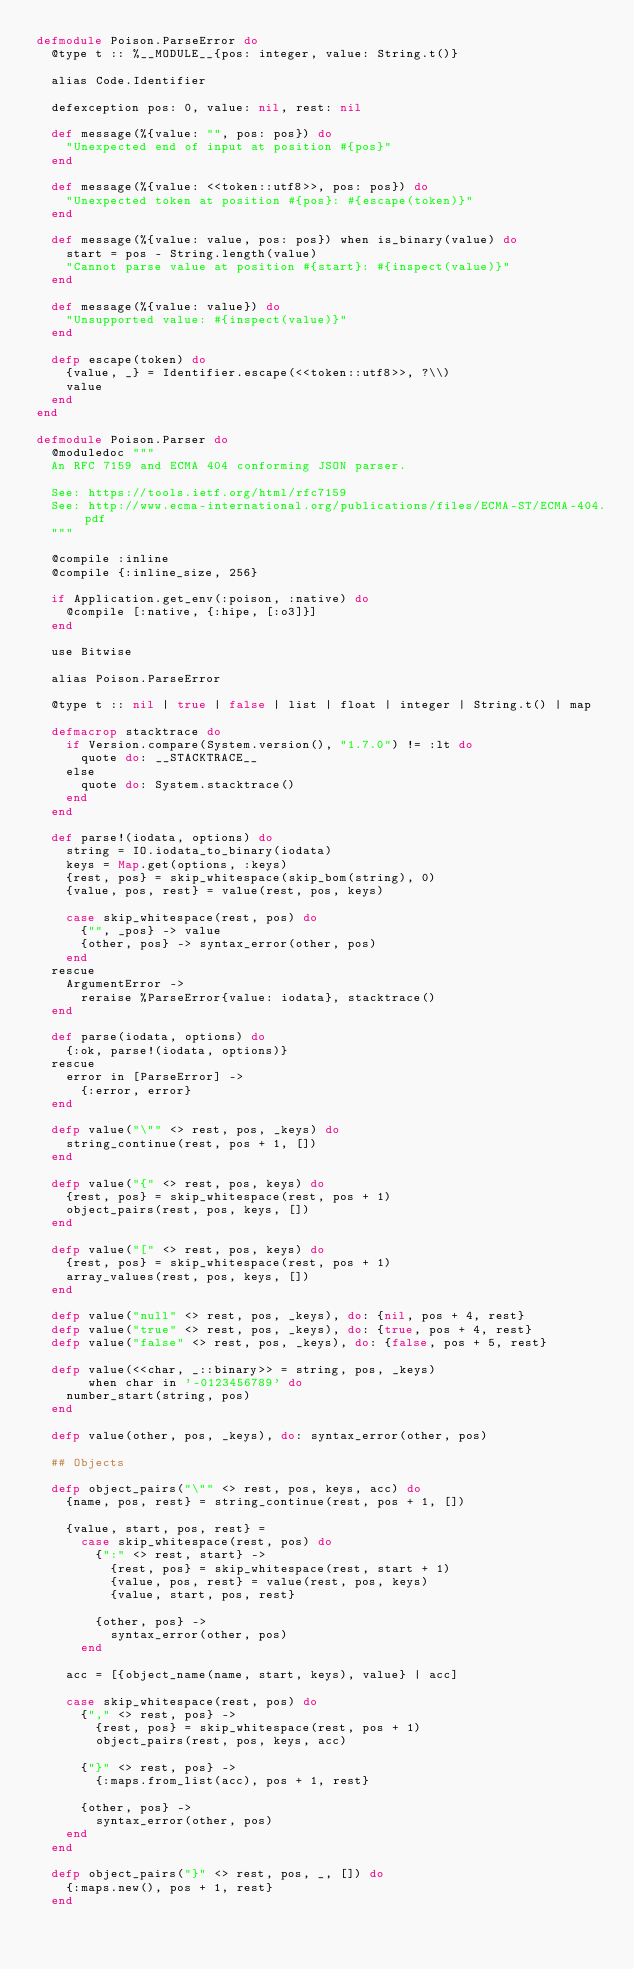Convert code to text. <code><loc_0><loc_0><loc_500><loc_500><_Elixir_>defmodule Poison.ParseError do
  @type t :: %__MODULE__{pos: integer, value: String.t()}

  alias Code.Identifier

  defexception pos: 0, value: nil, rest: nil

  def message(%{value: "", pos: pos}) do
    "Unexpected end of input at position #{pos}"
  end

  def message(%{value: <<token::utf8>>, pos: pos}) do
    "Unexpected token at position #{pos}: #{escape(token)}"
  end

  def message(%{value: value, pos: pos}) when is_binary(value) do
    start = pos - String.length(value)
    "Cannot parse value at position #{start}: #{inspect(value)}"
  end

  def message(%{value: value}) do
    "Unsupported value: #{inspect(value)}"
  end

  defp escape(token) do
    {value, _} = Identifier.escape(<<token::utf8>>, ?\\)
    value
  end
end

defmodule Poison.Parser do
  @moduledoc """
  An RFC 7159 and ECMA 404 conforming JSON parser.

  See: https://tools.ietf.org/html/rfc7159
  See: http://www.ecma-international.org/publications/files/ECMA-ST/ECMA-404.pdf
  """

  @compile :inline
  @compile {:inline_size, 256}

  if Application.get_env(:poison, :native) do
    @compile [:native, {:hipe, [:o3]}]
  end

  use Bitwise

  alias Poison.ParseError

  @type t :: nil | true | false | list | float | integer | String.t() | map

  defmacrop stacktrace do
    if Version.compare(System.version(), "1.7.0") != :lt do
      quote do: __STACKTRACE__
    else
      quote do: System.stacktrace()
    end
  end

  def parse!(iodata, options) do
    string = IO.iodata_to_binary(iodata)
    keys = Map.get(options, :keys)
    {rest, pos} = skip_whitespace(skip_bom(string), 0)
    {value, pos, rest} = value(rest, pos, keys)

    case skip_whitespace(rest, pos) do
      {"", _pos} -> value
      {other, pos} -> syntax_error(other, pos)
    end
  rescue
    ArgumentError ->
      reraise %ParseError{value: iodata}, stacktrace()
  end

  def parse(iodata, options) do
    {:ok, parse!(iodata, options)}
  rescue
    error in [ParseError] ->
      {:error, error}
  end

  defp value("\"" <> rest, pos, _keys) do
    string_continue(rest, pos + 1, [])
  end

  defp value("{" <> rest, pos, keys) do
    {rest, pos} = skip_whitespace(rest, pos + 1)
    object_pairs(rest, pos, keys, [])
  end

  defp value("[" <> rest, pos, keys) do
    {rest, pos} = skip_whitespace(rest, pos + 1)
    array_values(rest, pos, keys, [])
  end

  defp value("null" <> rest, pos, _keys), do: {nil, pos + 4, rest}
  defp value("true" <> rest, pos, _keys), do: {true, pos + 4, rest}
  defp value("false" <> rest, pos, _keys), do: {false, pos + 5, rest}

  defp value(<<char, _::binary>> = string, pos, _keys)
       when char in '-0123456789' do
    number_start(string, pos)
  end

  defp value(other, pos, _keys), do: syntax_error(other, pos)

  ## Objects

  defp object_pairs("\"" <> rest, pos, keys, acc) do
    {name, pos, rest} = string_continue(rest, pos + 1, [])

    {value, start, pos, rest} =
      case skip_whitespace(rest, pos) do
        {":" <> rest, start} ->
          {rest, pos} = skip_whitespace(rest, start + 1)
          {value, pos, rest} = value(rest, pos, keys)
          {value, start, pos, rest}

        {other, pos} ->
          syntax_error(other, pos)
      end

    acc = [{object_name(name, start, keys), value} | acc]

    case skip_whitespace(rest, pos) do
      {"," <> rest, pos} ->
        {rest, pos} = skip_whitespace(rest, pos + 1)
        object_pairs(rest, pos, keys, acc)

      {"}" <> rest, pos} ->
        {:maps.from_list(acc), pos + 1, rest}

      {other, pos} ->
        syntax_error(other, pos)
    end
  end

  defp object_pairs("}" <> rest, pos, _, []) do
    {:maps.new(), pos + 1, rest}
  end
</code> 